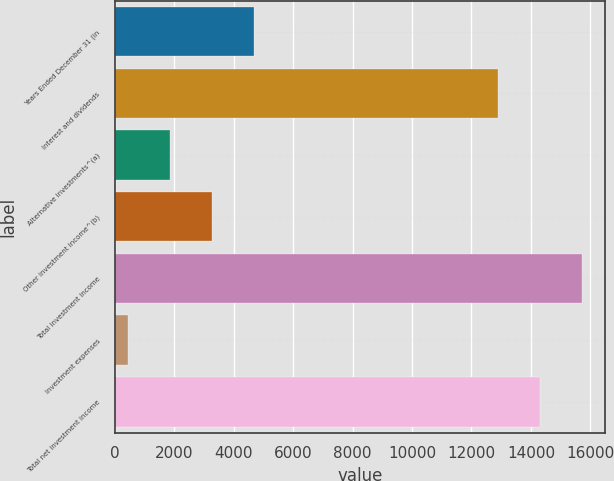<chart> <loc_0><loc_0><loc_500><loc_500><bar_chart><fcel>Years Ended December 31 (in<fcel>Interest and dividends<fcel>Alternative investments^(a)<fcel>Other investment income^(b)<fcel>Total investment income<fcel>Investment expenses<fcel>Total net investment income<nl><fcel>4672.5<fcel>12900<fcel>1859.5<fcel>3266<fcel>15713<fcel>453<fcel>14306.5<nl></chart> 